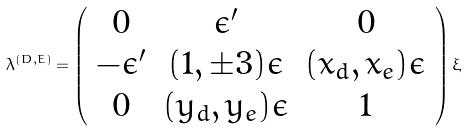<formula> <loc_0><loc_0><loc_500><loc_500>\lambda ^ { ( D , E ) } = \left ( \begin{array} { c c c } 0 & \epsilon ^ { \prime } & 0 \\ - \epsilon ^ { \prime } & ( 1 , \pm 3 ) \epsilon & ( x _ { d } , x _ { e } ) \epsilon \\ 0 & ( y _ { d } , y _ { e } ) \epsilon & 1 \end{array} \right ) \xi</formula> 